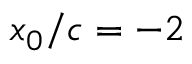Convert formula to latex. <formula><loc_0><loc_0><loc_500><loc_500>x _ { 0 } / c = - 2</formula> 